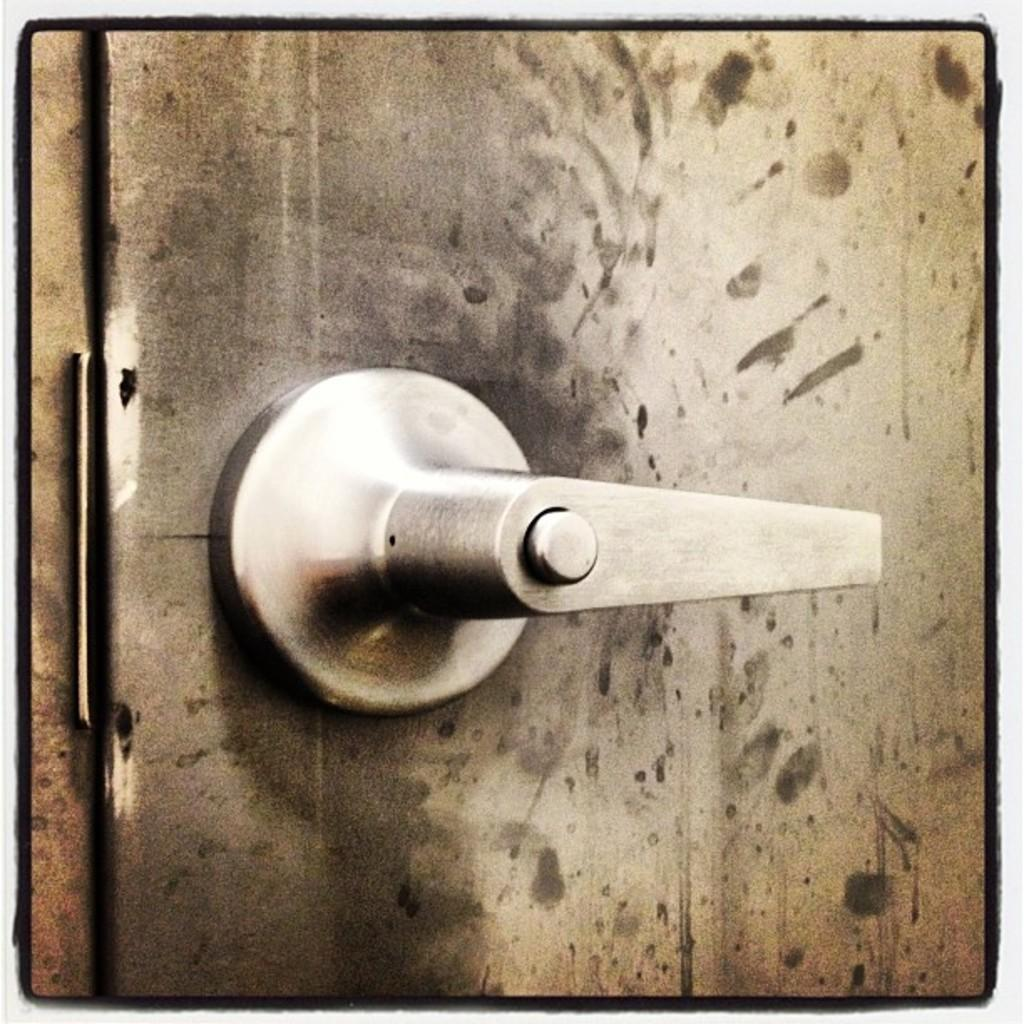What is located on the door in the image? There is a lock on the door in the image. What might the lock be used for? The lock might be used to secure the door and prevent unauthorized access. Can you describe the appearance of the lock? The lock appears to be a standard door lock, with a keyhole and a handle. What experience does the writer have with picking locks? There is no writer or reference to picking locks in the image, so it is not possible to answer that question. 